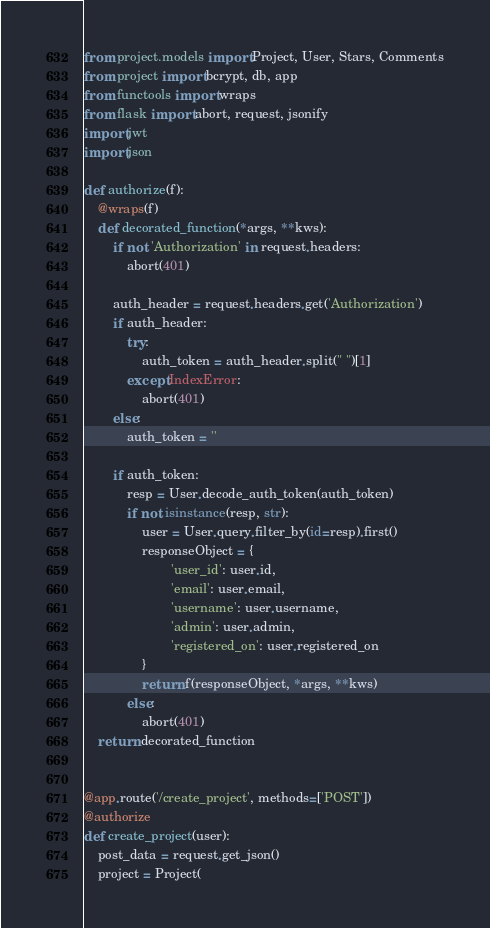Convert code to text. <code><loc_0><loc_0><loc_500><loc_500><_Python_>from project.models import Project, User, Stars, Comments
from project import bcrypt, db, app
from functools import wraps
from flask import abort, request, jsonify
import jwt
import json

def authorize(f):
	@wraps(f)
	def decorated_function(*args, **kws):
		if not 'Authorization' in request.headers:
			abort(401)

		auth_header = request.headers.get('Authorization')
		if auth_header:
			try:
				auth_token = auth_header.split(" ")[1]
			except IndexError:
				abort(401)
		else:
			auth_token = ''

		if auth_token:
			resp = User.decode_auth_token(auth_token)
			if not isinstance(resp, str):
				user = User.query.filter_by(id=resp).first()
				responseObject = {
						'user_id': user.id,
						'email': user.email,
						'username': user.username,
						'admin': user.admin,
						'registered_on': user.registered_on
				}
				return f(responseObject, *args, **kws)
			else:
				abort(401)
	return decorated_function


@app.route('/create_project', methods=['POST'])
@authorize
def create_project(user):
	post_data = request.get_json()
	project = Project(</code> 